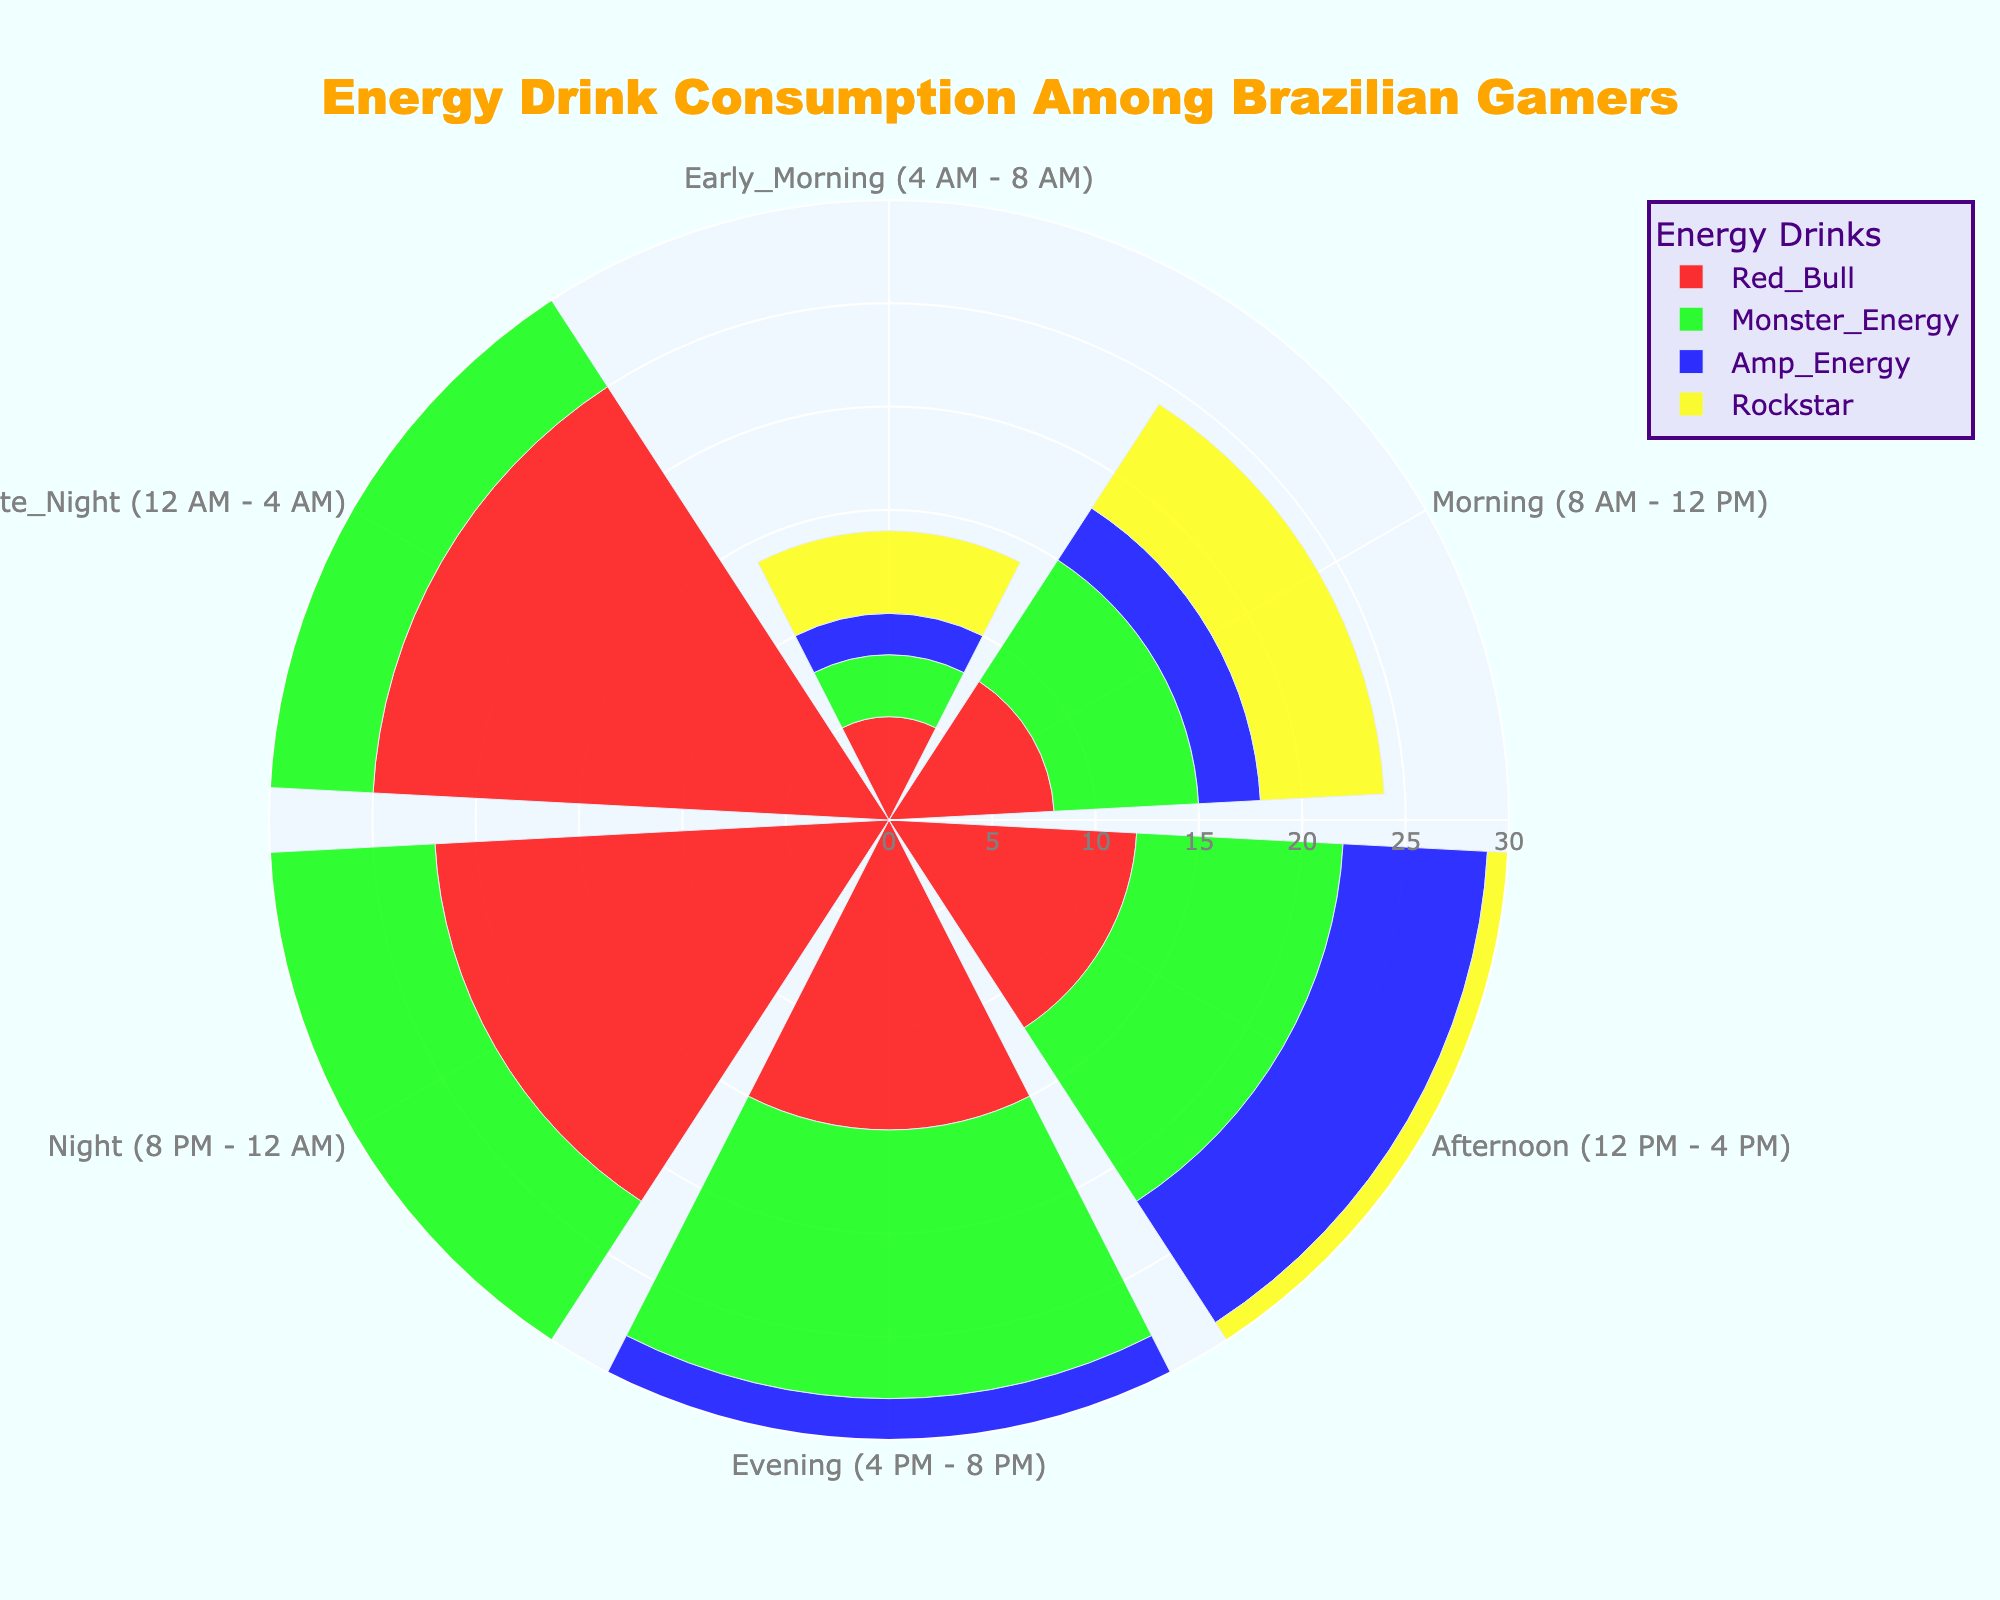How many energy drinks are consumed during the Evening (4 PM - 8 PM) according to the chart? To find the total consumption of energy drinks in the Evening, sum up the values for Red Bull, Monster Energy, Amp Energy, and Rockstar during this time slot: 15 + 13 + 8 + 11 = 47
Answer: 47 Which energy drink is consumed the most during Morning (8 AM - 12 PM)? Look at the values for each energy drink in the Morning slot: Red Bull (8), Monster Energy (7), Amp Energy (3), and Rockstar (6). Red Bull has the highest value.
Answer: Red Bull During what time of day does Rockstar have the highest consumption? Checking the values for Rockstar throughout the day, the highest is during Night (8 PM - 12 AM), which is 20.
Answer: Night (8 PM - 12 AM) What is the average consumption of Monster Energy across all time slots? Add the values for Monster Energy from all time slots and divide by the number of slots: (3 + 7 + 10 + 13 + 18 + 22)/6 = 73/6 ≈ 12.17
Answer: 12.17 Compare the consumption of Red Bull and Amp Energy during Early Morning (4 AM - 8 AM). Which is higher and by how much? Red Bull consumption in Early Morning is 5, Amp Energy is 2. The difference is 5 - 2 = 3.
Answer: Red Bull by 3 What is the total consumption of all energy drinks during Late Night (12 AM - 4 AM)? Sum the values for all energy drinks in Late Night: 25 (Red Bull) + 22 (Monster Energy) + 15 (Amp Energy) + 18 (Rockstar) = 80
Answer: 80 Between Amp Energy and Rockstar, which has more consistent daily consumption patterns and how can you tell? Amp Energy values are: 2, 3, 7, 8, 12, 15. Rockstar values are: 4, 6, 9, 11, 20, 18. Amp Energy shows a more consistent, gradual increase, whereas Rockstar has a sharp increase in Night and Late Night.
Answer: Amp Energy is more consistent How does the consumption of Monster Energy compare between Afternoon (12 PM - 4 PM) and Night (8 PM - 12 AM)? Monster Energy consumption in Afternoon is 10, while in Night it is 18. Therefore, during Night it is 18 - 10 = 8 units higher.
Answer: Night by 8 Which time slot has the highest total consumption of energy drinks and what is the total? Sum the total consumption for each time slot: Early Morning (14), Morning (24), Afternoon (38), Evening (47), Night (72), Late Night (80). Late Night has the highest at 80.
Answer: Late Night with 80 